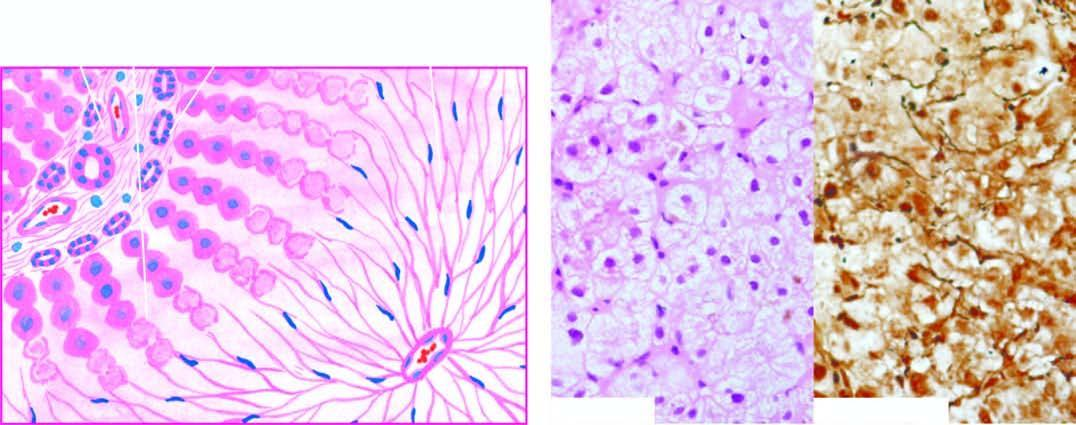s there no significant inflammation or fibrosis?
Answer the question using a single word or phrase. Yes 